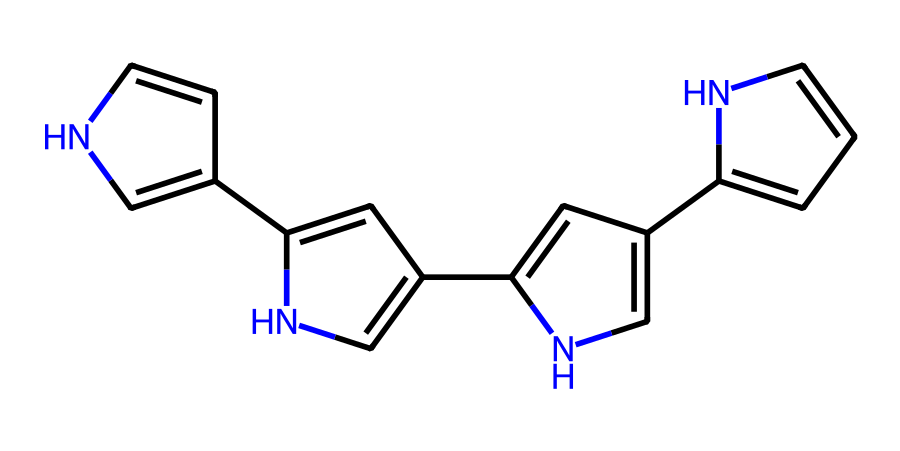What is the total number of nitrogen atoms in the structure? By examining the SMILES representation, each 'n' represents a nitrogen atom. There are four instances of 'n' and one instance of 'nH', which contributes one more nitrogen to the total count. Thus, 4 + 1 equals 5 nitrogen atoms.
Answer: 5 Which type of bonding is mainly present in this compound? The structure primarily consists of nitrogen and carbon atoms connected through single and double bonds, typical for aromatic compounds, which results in covalent bonding.
Answer: covalent Does the structure likely exhibit any aromatic characteristics? The presence of alternating double bonds and the cyclic nature of the compound suggest that this structure adheres to Huckel's rule, which indicates that it is aromatic.
Answer: yes What is the primary element present in this fiber's composition? The chemical structure contains multiple carbon (C) atoms, which are the most prevalent in the SMILES representation compared to other elements.
Answer: carbon What kind of functional groups could be present based on this molecular structure? The presence of nitrogen atoms and the cyclic framework suggest that the compound could belong to the class of heterocycles or might have amine-type functional groups.
Answer: heterocyclic How many rings are featured in the chemical structure? By analyzing the connectivity in the SMILES notation, we see that there are four interconnected rings evident from the cyclical connections between carbon and nitrogen atoms.
Answer: 4 